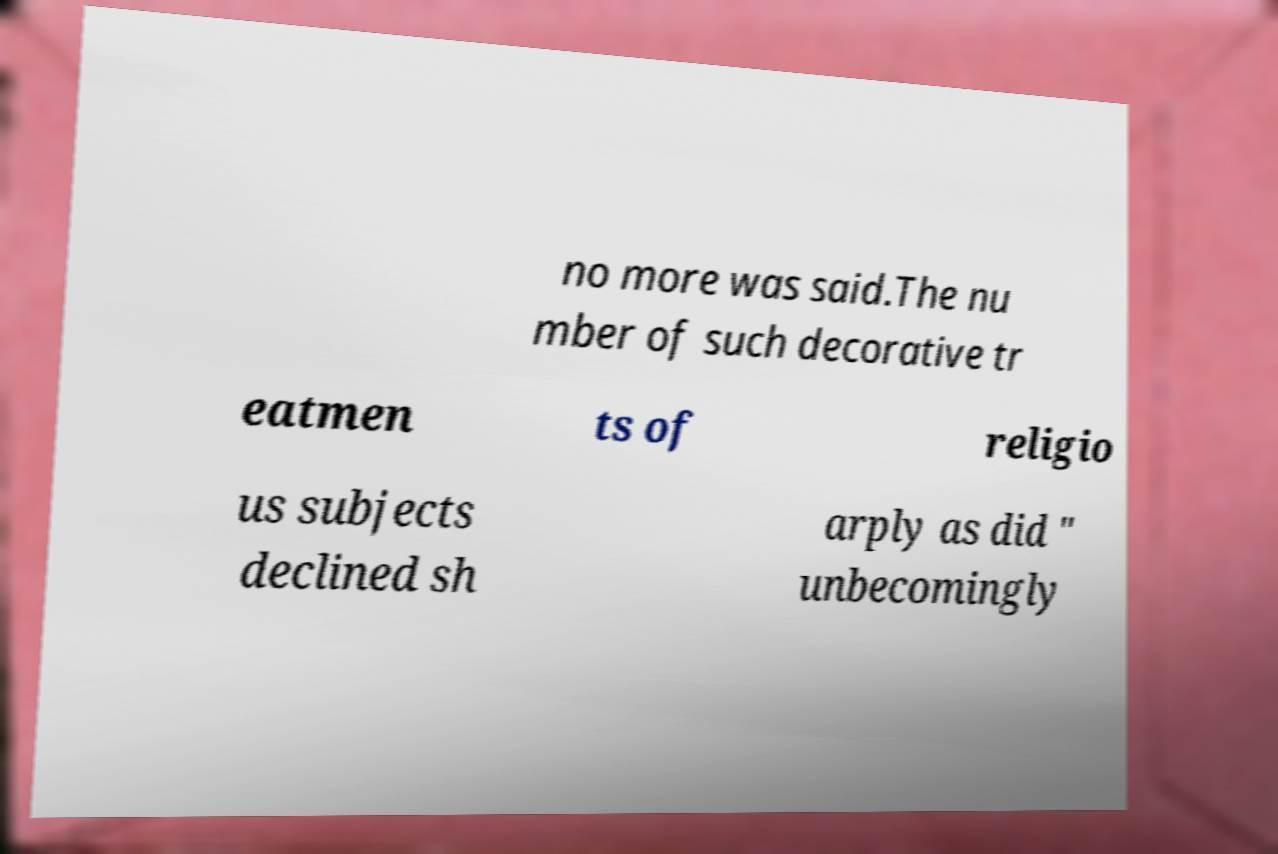Can you read and provide the text displayed in the image?This photo seems to have some interesting text. Can you extract and type it out for me? no more was said.The nu mber of such decorative tr eatmen ts of religio us subjects declined sh arply as did " unbecomingly 